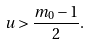<formula> <loc_0><loc_0><loc_500><loc_500>u > \frac { m _ { 0 } - 1 } { 2 } .</formula> 